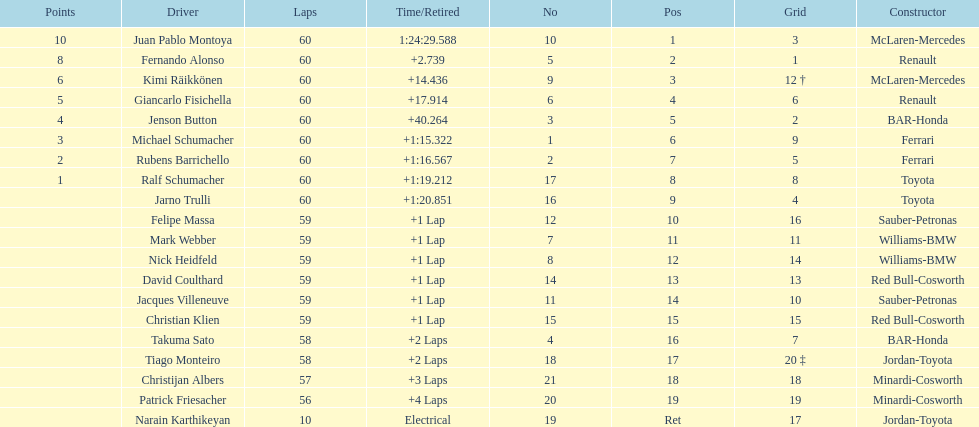Which racer has their starting position at 2? Jenson Button. 